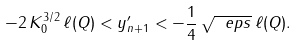Convert formula to latex. <formula><loc_0><loc_0><loc_500><loc_500>- 2 \, K _ { 0 } ^ { 3 / 2 } \, \ell ( Q ) < y ^ { \prime } _ { n + 1 } < - \frac { 1 } { 4 } \, \sqrt { \ e p s } \, \ell ( Q ) .</formula> 